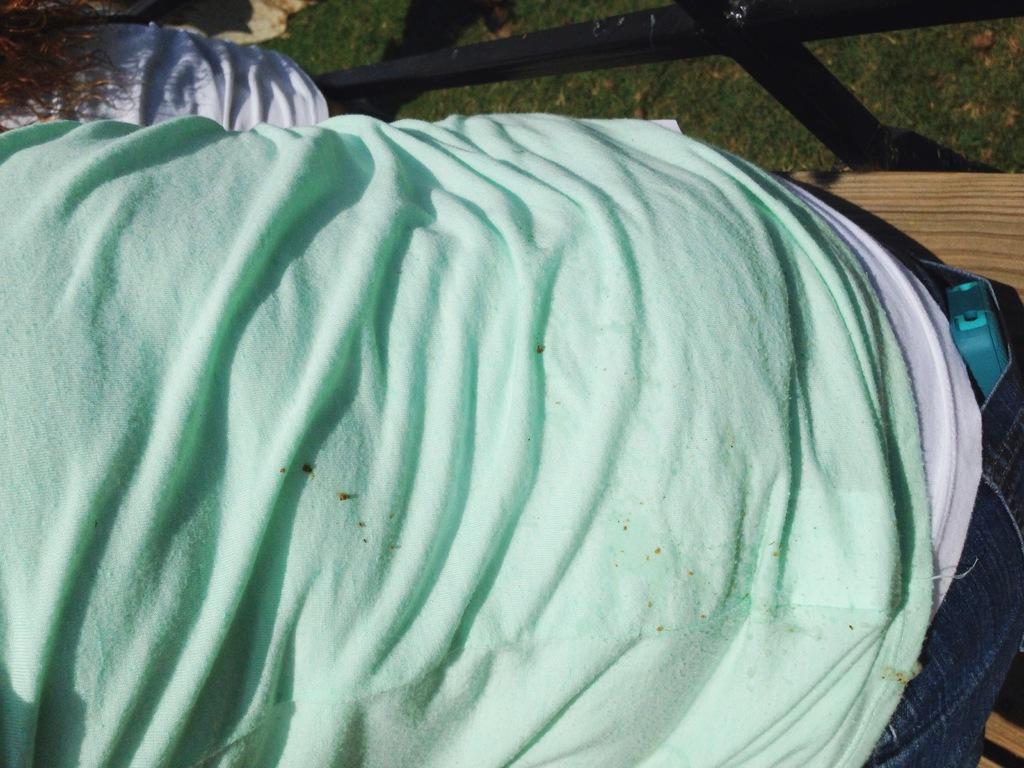Can you describe this image briefly? In this image we can see that they are looking like two persons. In the background of the image there is the grass and other objects. 